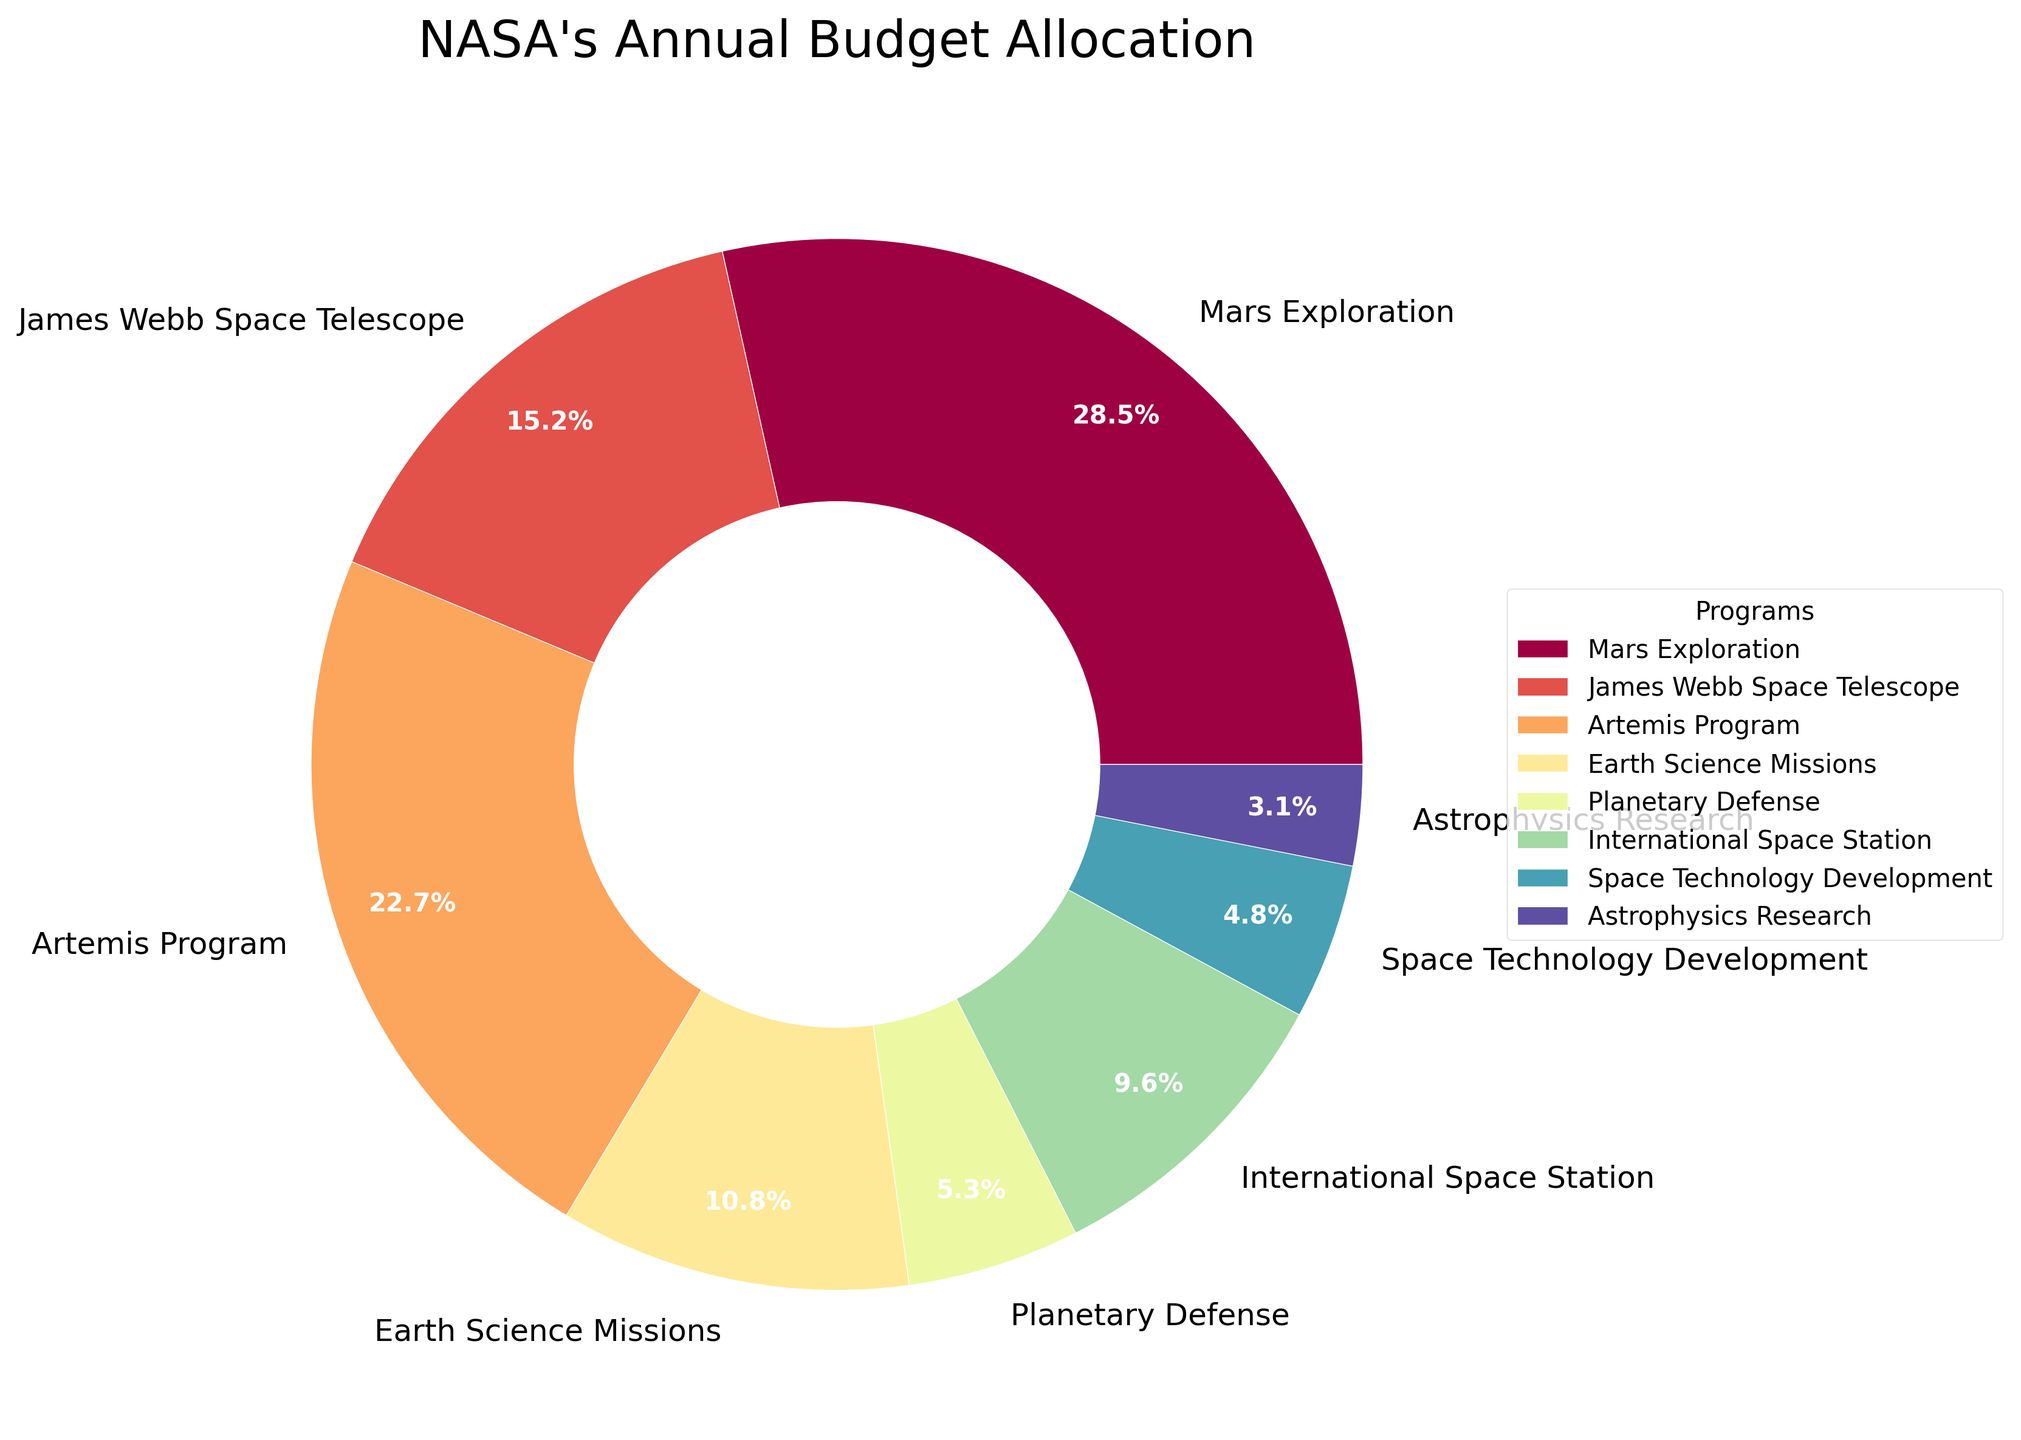What's the largest allocation in the budget? Look at the pie chart and identify the slice with the largest percentage allocation. The Mars Exploration program has the largest slice at 28.5%.
Answer: Mars Exploration How does the allocation for Earth Science Missions compare to that for International Space Station? Compare the sizes of the slices for Earth Science Missions and International Space Station. Earth Science Missions is 10.8%, and International Space Station is 9.6%. Therefore, Earth Science Missions has a slightly higher allocation.
Answer: Earth Science Missions has a higher allocation What's the combined allocation for James Webb Space Telescope and Astrophysics Research? Sum the percentages for the James Webb Space Telescope (15.2%) and Astrophysics Research (3.1%). The total allocation is 15.2% + 3.1% = 18.3%.
Answer: 18.3% Which program receives the second highest budget allocation? Look for the second largest slice in the pie chart. The Artemis Program comes after Mars Exploration at 22.7%.
Answer: Artemis Program How does the allocation for Space Technology Development compare to Planetary Defense? Compare the percentages for Space Technology Development (4.8%) and Planetary Defense (5.3%). Planetary Defense has a slightly higher allocation.
Answer: Planetary Defense is higher Which program has the smallest allocation and what is its percentage? Identify the smallest slice in the pie chart. Astrophysics Research has the smallest allocation, which is 3.1%.
Answer: Astrophysics Research at 3.1% What is the difference between the budget allocations for Mars Exploration and Artemis Program? Subtract the percentage of the Artemis Program (22.7%) from the Mars Exploration (28.5%). The difference is 28.5% - 22.7% = 5.8%.
Answer: 5.8% Rank the top three programs by their budget allocation. Identify the top three slices in the pie chart by their size. The top three are Mars Exploration (28.5%), Artemis Program (22.7%), and James Webb Space Telescope (15.2%).
Answer: Mars Exploration, Artemis Program, James Webb Space Telescope What is the total budget allocation for Earth Science Missions, International Space Station, and Space Technology Development combined? Sum the percentages for Earth Science Missions (10.8%), International Space Station (9.6%), and Space Technology Development (4.8%). The combined allocation is 10.8% + 9.6% + 4.8% = 25.2%.
Answer: 25.2% 